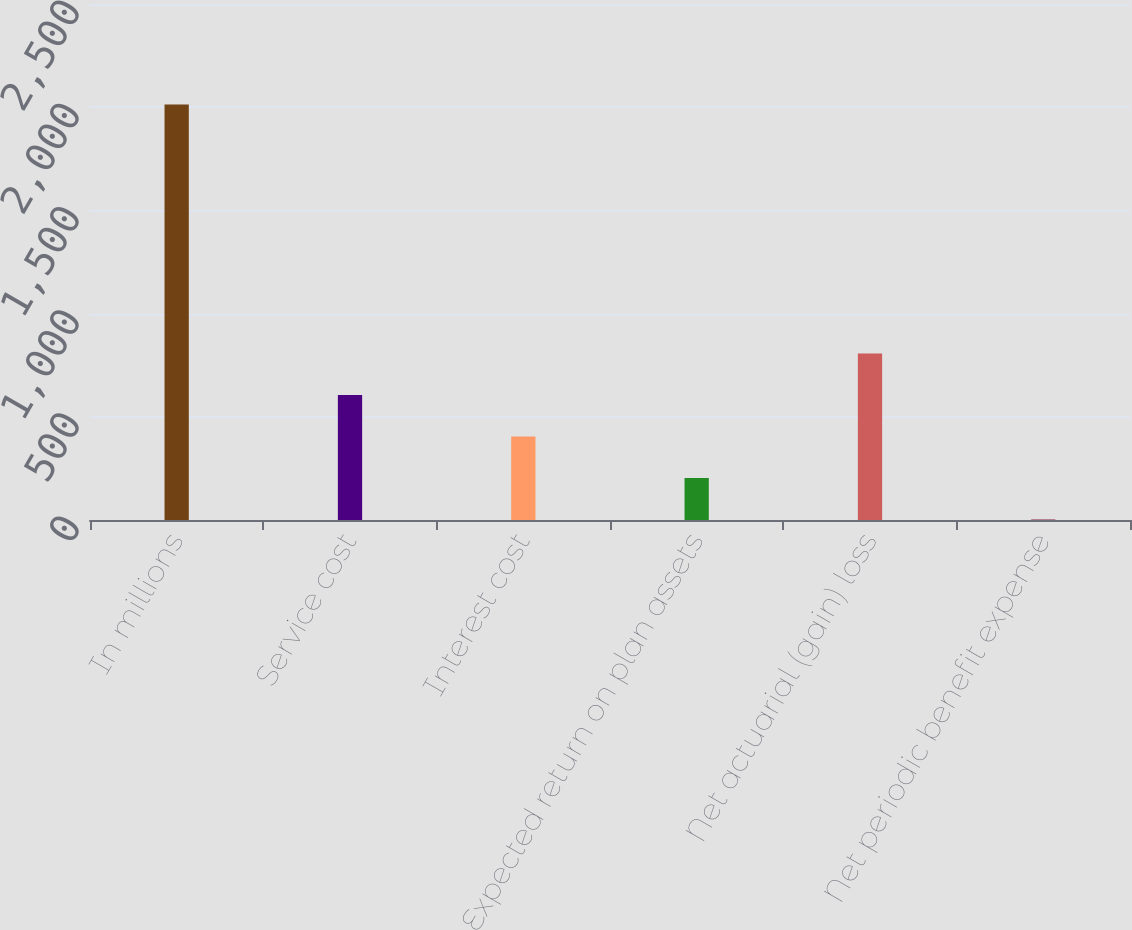<chart> <loc_0><loc_0><loc_500><loc_500><bar_chart><fcel>In millions<fcel>Service cost<fcel>Interest cost<fcel>Expected return on plan assets<fcel>Net actuarial (gain) loss<fcel>Net periodic benefit expense<nl><fcel>2013<fcel>605.51<fcel>404.44<fcel>203.37<fcel>806.58<fcel>2.3<nl></chart> 